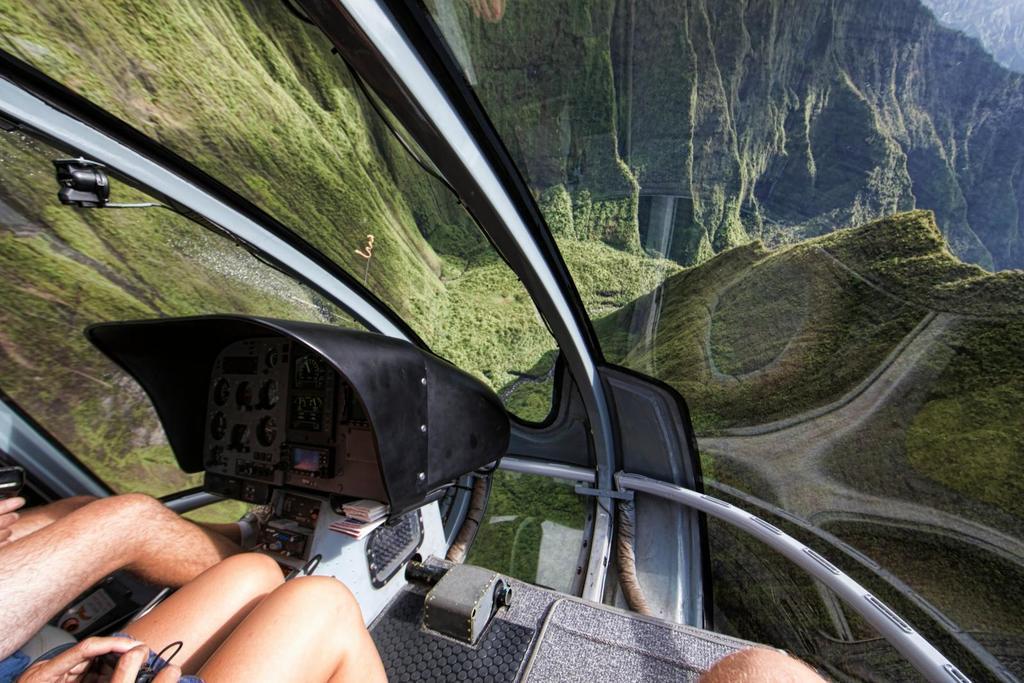In one or two sentences, can you explain what this image depicts? At the bottom, we can see human legs. Here we can see some machine and glass. Through the glass we can see the outside view. Here we can see few mountains with plants. 